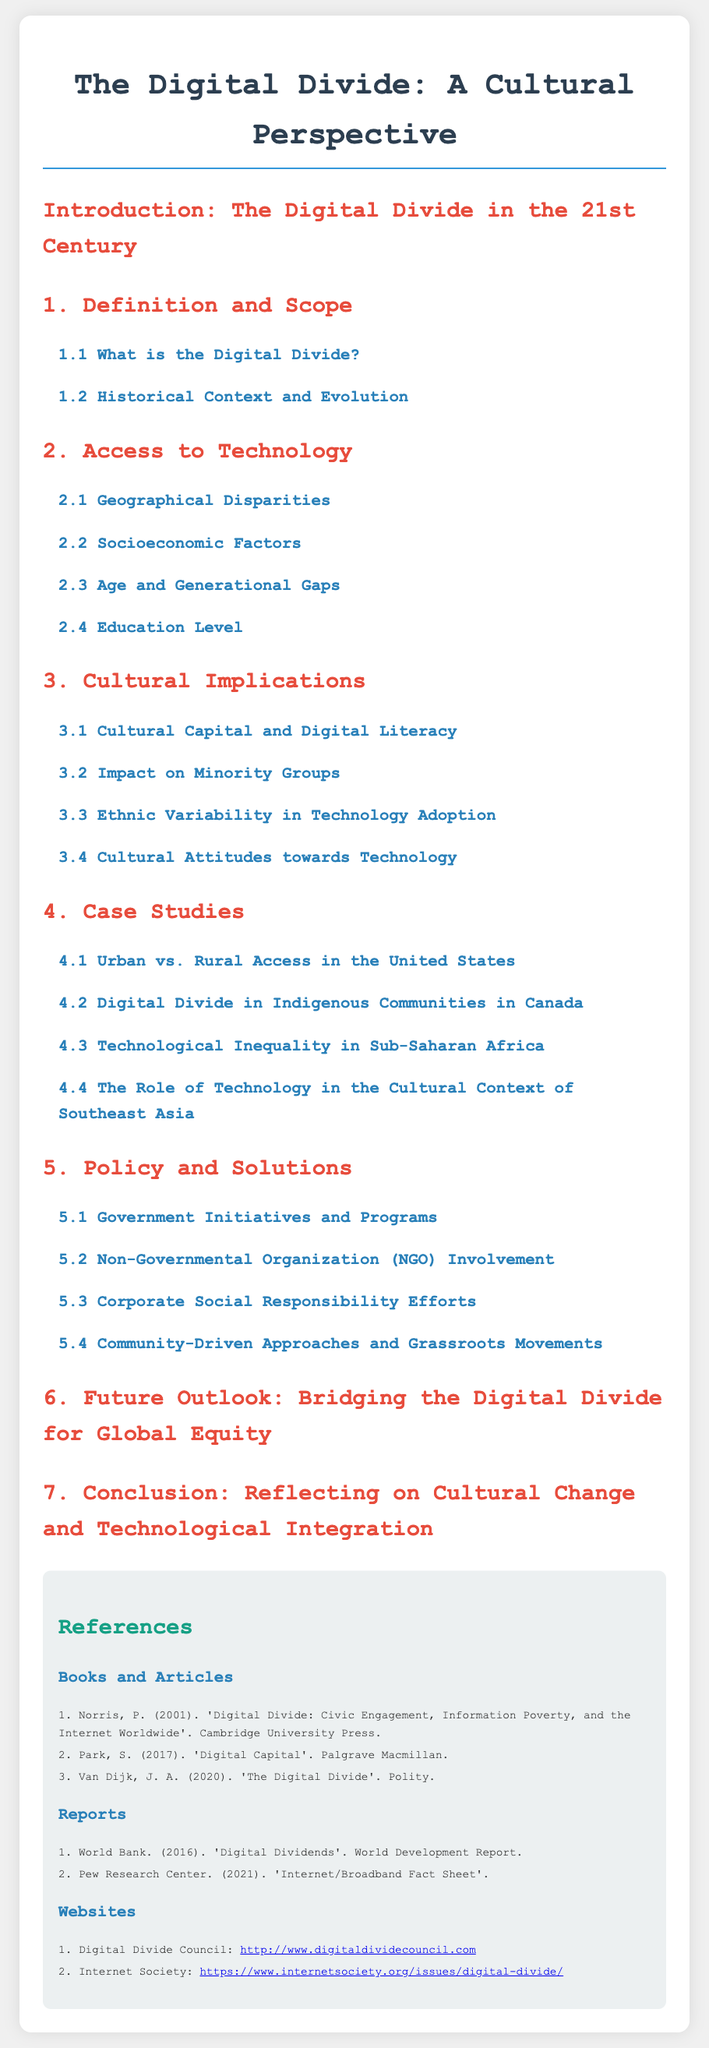What is the title of the document? The title is clearly stated at the beginning of the document.
Answer: The Digital Divide: A Cultural Perspective What section discusses "Geographical Disparities"? The sections are organized with headings, and this specific topic is listed under Access to Technology.
Answer: 2.1 Geographical Disparities Who are the authors mentioned in the references? The references include books and articles, and the authors are directly listed in this section.
Answer: Norris, Park, Van Dijk Which case study focuses on Indigenous Communities? The case studies provide specific examples, one of which directly relates to Indigenous Communities.
Answer: 4.2 Digital Divide in Indigenous Communities in Canada What type of initiatives are discussed in section 5? This section addresses various efforts to address the digital divide, including organizations and programs.
Answer: Government Initiatives and Programs What impact does technology have on minority groups? This question relates to the cultural implications highlighted in the document, specifically in section 3.
Answer: 3.2 Impact on Minority Groups How many reports are listed in the references? The number of reports can be counted from the references section specifically dedicated to them.
Answer: 2 What is the main focus of section 6? Section 6 addresses future considerations regarding technology and equity, which is its central theme.
Answer: Bridging the Digital Divide for Global Equity What cultural aspect does section 3.4 discuss? This section looks specifically at societal attitudes towards technology, presenting a cultural perspective.
Answer: Cultural Attitudes towards Technology 